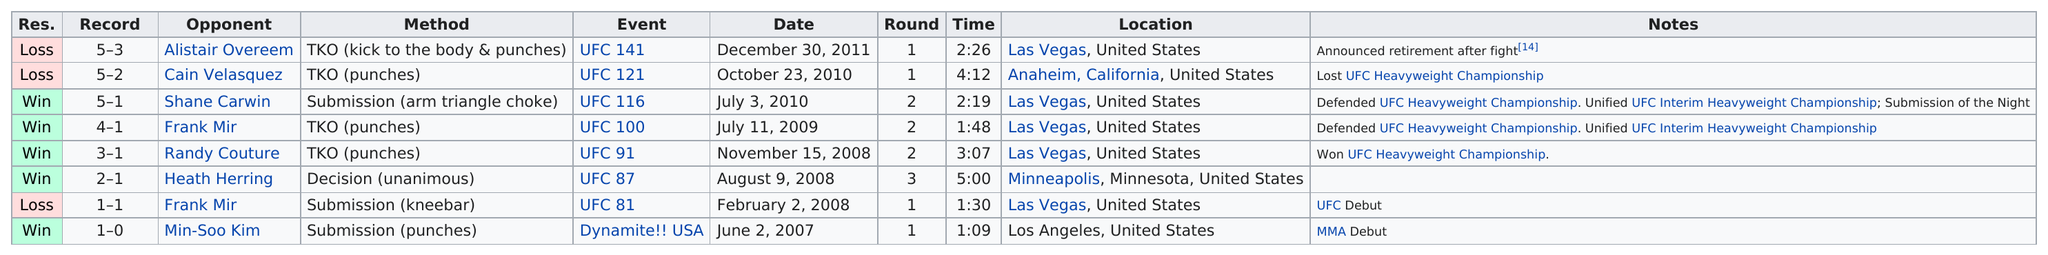Draw attention to some important aspects in this diagram. Shane Carwin has the most and best score. After UFC 121, the next event in the UFC calendar is UFC 116. On July 3, 2010, Brock Lesnar successfully defended the UFC Heavyweight Championship, marking the last time he successfully defended the title. Out of the total number of fights that lasted at least two rounds, 4 were recorded. After his second fight with Frank Mir, in which he won via TKO, the fighter went on to fight Shane Carwin in his next bout. 